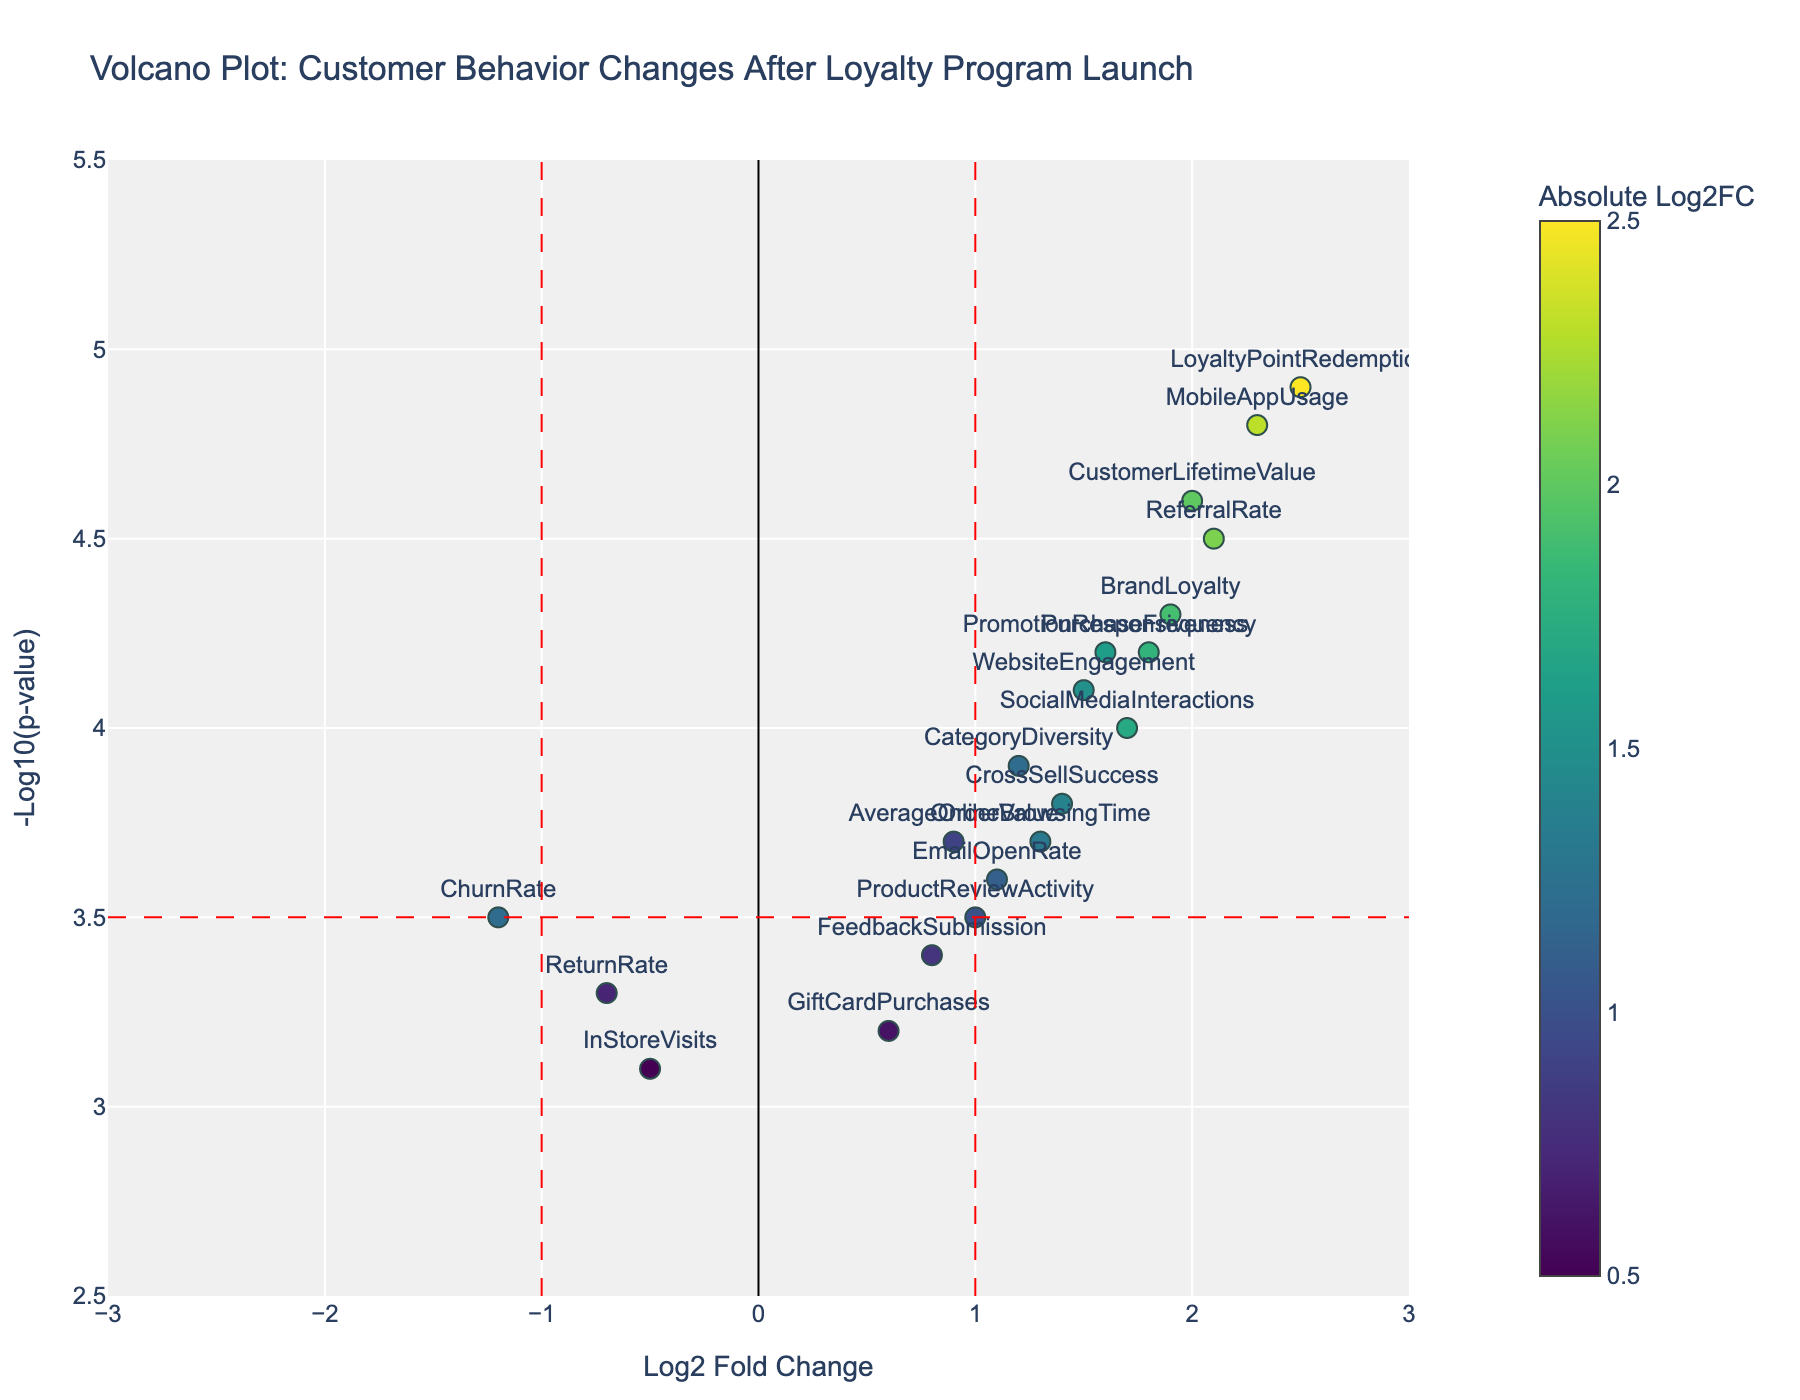How many data points have a Log2 Fold Change greater than 1 and a -Log10(p-value) higher than 3.5? First, identify the threshold lines on the plot: a vertical line at Log2 Fold Change = 1 and a horizontal line at -Log10(p-value) = 3.5. Then, count the points in the top-right quadrant, above and to the right of these lines. The points meeting these conditions are seven: PurchaseFrequency, ReferralRate, WebsiteEngagement, MobileAppUsage, SocialMediaInteractions, CustomerLifetimeValue, and BrandLoyalty.
Answer: 7 Which behavior shows the highest Log2 Fold Change? To find this, look for the data point positioned furthest to the right. The behavior with the highest Log2 Fold Change is LoyaltyPointRedemption with a value of 2.5.
Answer: LoyaltyPointRedemption Which data points are downregulated according to the plot? Downregulated points are those with negative Log2 Fold Changes. From the plot, the behaviors falling to the left of the Log2 Fold Change = 0 line are ReturnRate, ChurnRate, and InStoreVisits.
Answer: ReturnRate, ChurnRate, InStoreVisits Is there any behavior that appears close to being not significant according to the p-value threshold but still shows a change? Behaviors near the -Log10(p-value) threshold of 3.5 can be identified. FeedbackSubmission and ProductReviewActivity lie closest to this threshold line but still show a change.
Answer: FeedbackSubmission, ProductReviewActivity Which data point has a significant upregulation of customer behavior after the loyalty program launch and the highest -Log10(p-value)? Look for the data point in the top-right quadrant with the highest vertical positioning. This is MobileAppUsage with a -Log10(p-value) of 4.8.
Answer: MobileAppUsage How does EmailOpenRate compare to SocialMediaInteractions in terms of Log2 Fold Change and -Log10(p-value)? Compare the positions of EmailOpenRate and SocialMediaInteractions on the plot. EmailOpenRate has a Log2 Fold Change of 1.1 and a -Log10(p-value) of 3.6, whereas SocialMediaInteractions has a Log2 Fold Change of 1.7 and a -Log10(p-value) of 4.0. SocialMediaInteractions has both higher Log2 Fold Change and -Log10(p-value).
Answer: SocialMediaInteractions has a higher Log2 Fold Change and -Log10(p-value) What is the Log2 Fold Change and -Log10(p-value) for CustomerLifetimeValue? Find the exact coordinates for CustomerLifetimeValue on the plot. It’s positioned at Log2 Fold Change of 2.0 and -Log10(p-value) of 4.6.
Answer: Log2FC: 2.0, -Log10(p-value): 4.6 